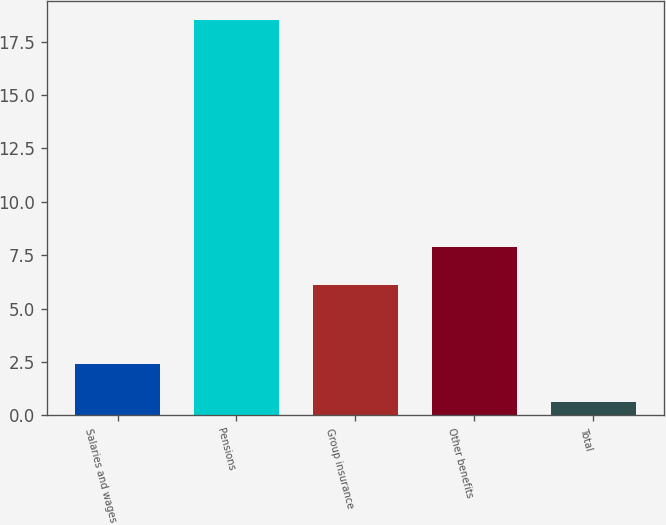<chart> <loc_0><loc_0><loc_500><loc_500><bar_chart><fcel>Salaries and wages<fcel>Pensions<fcel>Group insurance<fcel>Other benefits<fcel>Total<nl><fcel>2.39<fcel>18.5<fcel>6.1<fcel>7.89<fcel>0.6<nl></chart> 